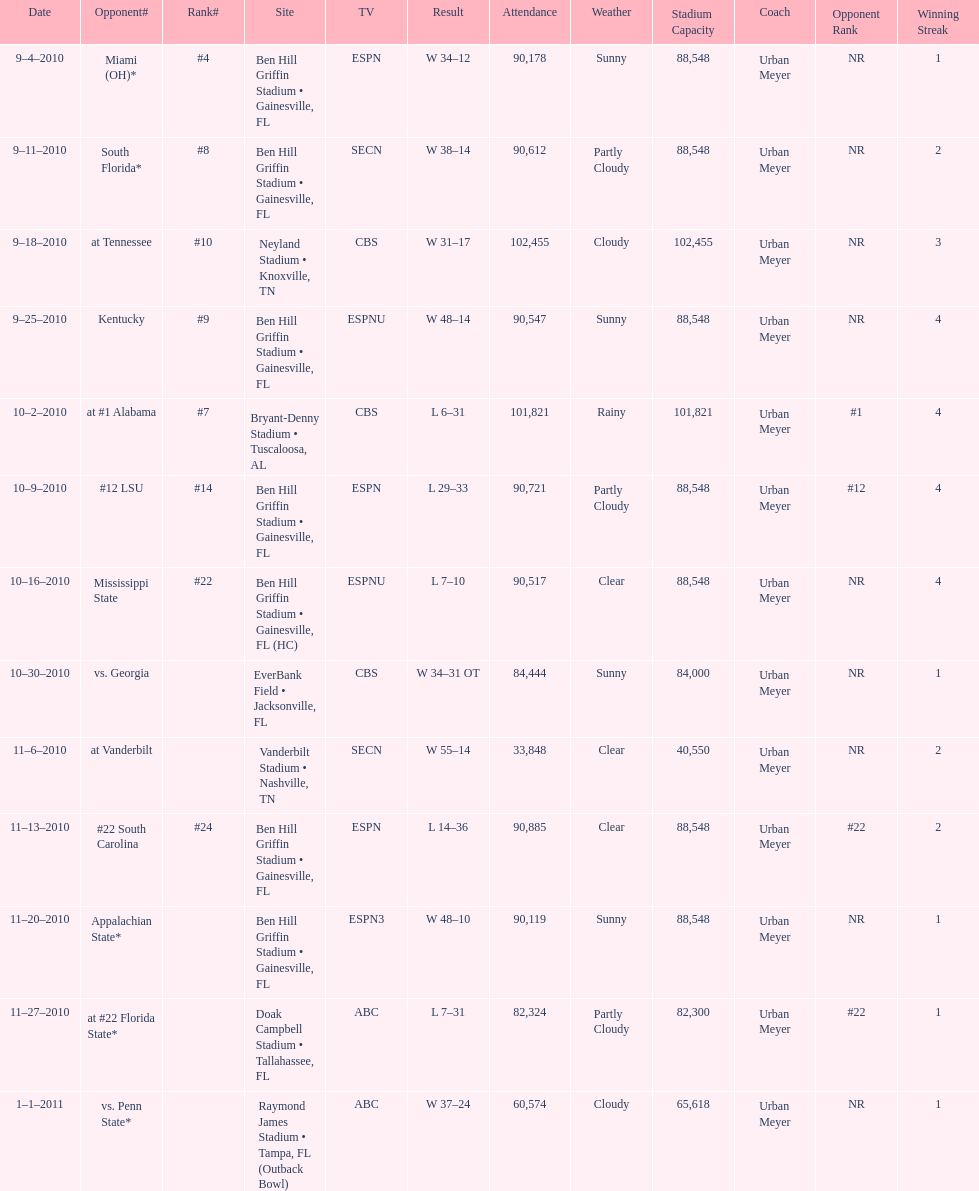Could you parse the entire table? {'header': ['Date', 'Opponent#', 'Rank#', 'Site', 'TV', 'Result', 'Attendance', 'Weather', 'Stadium Capacity', 'Coach', 'Opponent Rank', 'Winning Streak'], 'rows': [['9–4–2010', 'Miami (OH)*', '#4', 'Ben Hill Griffin Stadium • Gainesville, FL', 'ESPN', 'W\xa034–12', '90,178', 'Sunny', '88,548', 'Urban Meyer', 'NR', '1'], ['9–11–2010', 'South Florida*', '#8', 'Ben Hill Griffin Stadium • Gainesville, FL', 'SECN', 'W\xa038–14', '90,612', 'Partly Cloudy', '88,548', 'Urban Meyer', 'NR', '2'], ['9–18–2010', 'at\xa0Tennessee', '#10', 'Neyland Stadium • Knoxville, TN', 'CBS', 'W\xa031–17', '102,455', 'Cloudy', '102,455', 'Urban Meyer', 'NR', '3'], ['9–25–2010', 'Kentucky', '#9', 'Ben Hill Griffin Stadium • Gainesville, FL', 'ESPNU', 'W\xa048–14', '90,547', 'Sunny', '88,548', 'Urban Meyer', 'NR', '4'], ['10–2–2010', 'at\xa0#1\xa0Alabama', '#7', 'Bryant-Denny Stadium • Tuscaloosa, AL', 'CBS', 'L\xa06–31', '101,821', 'Rainy', '101,821', 'Urban Meyer', '#1', '4'], ['10–9–2010', '#12\xa0LSU', '#14', 'Ben Hill Griffin Stadium • Gainesville, FL', 'ESPN', 'L\xa029–33', '90,721', 'Partly Cloudy', '88,548', 'Urban Meyer', '#12', '4'], ['10–16–2010', 'Mississippi State', '#22', 'Ben Hill Griffin Stadium • Gainesville, FL (HC)', 'ESPNU', 'L\xa07–10', '90,517', 'Clear', '88,548', 'Urban Meyer', 'NR', '4'], ['10–30–2010', 'vs.\xa0Georgia', '', 'EverBank Field • Jacksonville, FL', 'CBS', 'W\xa034–31\xa0OT', '84,444', 'Sunny', '84,000', 'Urban Meyer', 'NR', '1'], ['11–6–2010', 'at\xa0Vanderbilt', '', 'Vanderbilt Stadium • Nashville, TN', 'SECN', 'W\xa055–14', '33,848', 'Clear', '40,550', 'Urban Meyer', 'NR', '2'], ['11–13–2010', '#22\xa0South Carolina', '#24', 'Ben Hill Griffin Stadium • Gainesville, FL', 'ESPN', 'L\xa014–36', '90,885', 'Clear', '88,548', 'Urban Meyer', '#22', '2'], ['11–20–2010', 'Appalachian State*', '', 'Ben Hill Griffin Stadium • Gainesville, FL', 'ESPN3', 'W\xa048–10', '90,119', 'Sunny', '88,548', 'Urban Meyer', 'NR', '1'], ['11–27–2010', 'at\xa0#22\xa0Florida State*', '', 'Doak Campbell Stadium • Tallahassee, FL', 'ABC', 'L\xa07–31', '82,324', 'Partly Cloudy', '82,300', 'Urban Meyer', '#22', '1'], ['1–1–2011', 'vs.\xa0Penn State*', '', 'Raymond James Stadium • Tampa, FL (Outback Bowl)', 'ABC', 'W\xa037–24', '60,574', 'Cloudy', '65,618', 'Urban Meyer', 'NR', '1']]} What tv network showed the largest number of games during the 2010/2011 season? ESPN. 